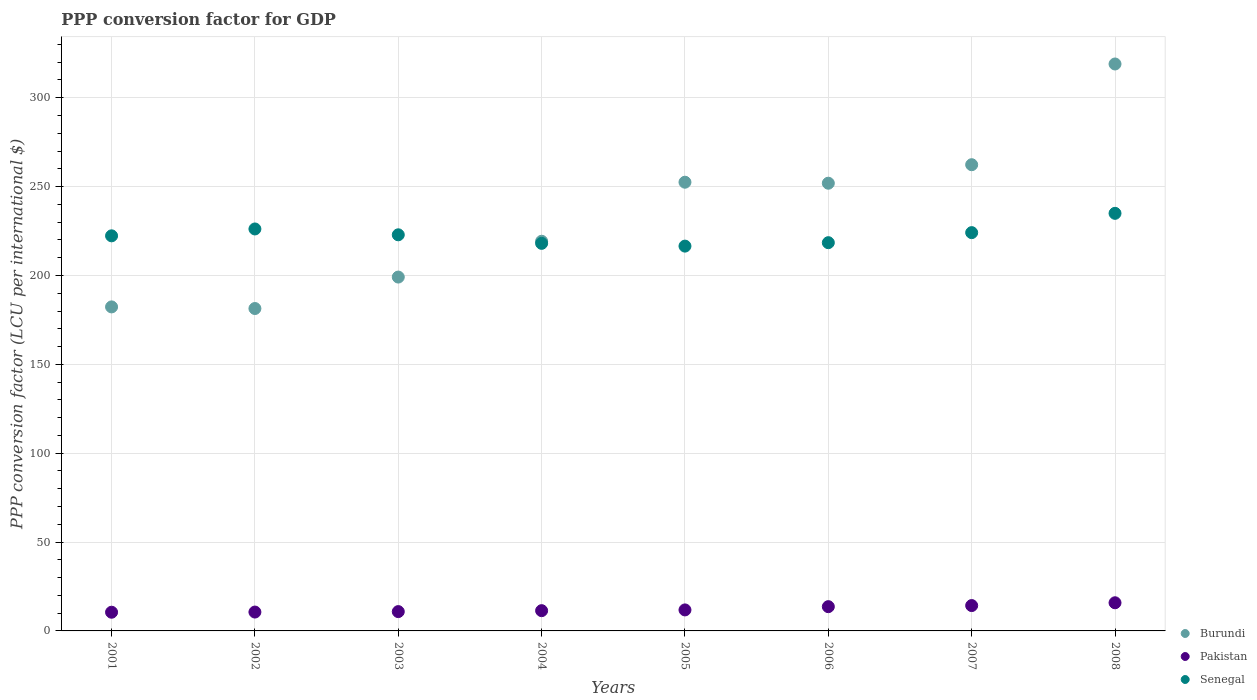How many different coloured dotlines are there?
Offer a very short reply. 3. Is the number of dotlines equal to the number of legend labels?
Ensure brevity in your answer.  Yes. What is the PPP conversion factor for GDP in Burundi in 2001?
Keep it short and to the point. 182.31. Across all years, what is the maximum PPP conversion factor for GDP in Senegal?
Make the answer very short. 234.95. Across all years, what is the minimum PPP conversion factor for GDP in Burundi?
Ensure brevity in your answer.  181.4. In which year was the PPP conversion factor for GDP in Burundi minimum?
Offer a very short reply. 2002. What is the total PPP conversion factor for GDP in Senegal in the graph?
Give a very brief answer. 1783.41. What is the difference between the PPP conversion factor for GDP in Pakistan in 2002 and that in 2003?
Offer a very short reply. -0.25. What is the difference between the PPP conversion factor for GDP in Pakistan in 2003 and the PPP conversion factor for GDP in Burundi in 2008?
Provide a succinct answer. -308.12. What is the average PPP conversion factor for GDP in Senegal per year?
Provide a short and direct response. 222.93. In the year 2001, what is the difference between the PPP conversion factor for GDP in Burundi and PPP conversion factor for GDP in Senegal?
Your response must be concise. -39.99. What is the ratio of the PPP conversion factor for GDP in Senegal in 2002 to that in 2004?
Give a very brief answer. 1.04. Is the difference between the PPP conversion factor for GDP in Burundi in 2003 and 2005 greater than the difference between the PPP conversion factor for GDP in Senegal in 2003 and 2005?
Offer a terse response. No. What is the difference between the highest and the second highest PPP conversion factor for GDP in Pakistan?
Your response must be concise. 1.57. What is the difference between the highest and the lowest PPP conversion factor for GDP in Pakistan?
Provide a short and direct response. 5.32. Is the sum of the PPP conversion factor for GDP in Senegal in 2003 and 2005 greater than the maximum PPP conversion factor for GDP in Burundi across all years?
Give a very brief answer. Yes. Is it the case that in every year, the sum of the PPP conversion factor for GDP in Pakistan and PPP conversion factor for GDP in Burundi  is greater than the PPP conversion factor for GDP in Senegal?
Give a very brief answer. No. Does the PPP conversion factor for GDP in Senegal monotonically increase over the years?
Ensure brevity in your answer.  No. Is the PPP conversion factor for GDP in Burundi strictly less than the PPP conversion factor for GDP in Senegal over the years?
Give a very brief answer. No. How many dotlines are there?
Make the answer very short. 3. Are the values on the major ticks of Y-axis written in scientific E-notation?
Keep it short and to the point. No. Does the graph contain any zero values?
Give a very brief answer. No. How many legend labels are there?
Your answer should be very brief. 3. How are the legend labels stacked?
Keep it short and to the point. Vertical. What is the title of the graph?
Offer a terse response. PPP conversion factor for GDP. Does "Liechtenstein" appear as one of the legend labels in the graph?
Your response must be concise. No. What is the label or title of the X-axis?
Offer a very short reply. Years. What is the label or title of the Y-axis?
Provide a short and direct response. PPP conversion factor (LCU per international $). What is the PPP conversion factor (LCU per international $) of Burundi in 2001?
Give a very brief answer. 182.31. What is the PPP conversion factor (LCU per international $) in Pakistan in 2001?
Offer a terse response. 10.52. What is the PPP conversion factor (LCU per international $) in Senegal in 2001?
Give a very brief answer. 222.3. What is the PPP conversion factor (LCU per international $) in Burundi in 2002?
Your answer should be very brief. 181.4. What is the PPP conversion factor (LCU per international $) in Pakistan in 2002?
Give a very brief answer. 10.61. What is the PPP conversion factor (LCU per international $) in Senegal in 2002?
Ensure brevity in your answer.  226.16. What is the PPP conversion factor (LCU per international $) in Burundi in 2003?
Provide a succinct answer. 199.1. What is the PPP conversion factor (LCU per international $) in Pakistan in 2003?
Your answer should be compact. 10.87. What is the PPP conversion factor (LCU per international $) in Senegal in 2003?
Your answer should be compact. 222.88. What is the PPP conversion factor (LCU per international $) in Burundi in 2004?
Make the answer very short. 219.24. What is the PPP conversion factor (LCU per international $) in Pakistan in 2004?
Your answer should be compact. 11.4. What is the PPP conversion factor (LCU per international $) in Senegal in 2004?
Provide a short and direct response. 218.06. What is the PPP conversion factor (LCU per international $) in Burundi in 2005?
Make the answer very short. 252.46. What is the PPP conversion factor (LCU per international $) of Pakistan in 2005?
Keep it short and to the point. 11.82. What is the PPP conversion factor (LCU per international $) of Senegal in 2005?
Provide a succinct answer. 216.51. What is the PPP conversion factor (LCU per international $) of Burundi in 2006?
Ensure brevity in your answer.  251.91. What is the PPP conversion factor (LCU per international $) of Pakistan in 2006?
Your response must be concise. 13.65. What is the PPP conversion factor (LCU per international $) of Senegal in 2006?
Give a very brief answer. 218.44. What is the PPP conversion factor (LCU per international $) of Burundi in 2007?
Your response must be concise. 262.31. What is the PPP conversion factor (LCU per international $) in Pakistan in 2007?
Provide a short and direct response. 14.26. What is the PPP conversion factor (LCU per international $) of Senegal in 2007?
Your answer should be very brief. 224.1. What is the PPP conversion factor (LCU per international $) of Burundi in 2008?
Your answer should be compact. 318.99. What is the PPP conversion factor (LCU per international $) of Pakistan in 2008?
Give a very brief answer. 15.84. What is the PPP conversion factor (LCU per international $) of Senegal in 2008?
Ensure brevity in your answer.  234.95. Across all years, what is the maximum PPP conversion factor (LCU per international $) of Burundi?
Provide a succinct answer. 318.99. Across all years, what is the maximum PPP conversion factor (LCU per international $) of Pakistan?
Make the answer very short. 15.84. Across all years, what is the maximum PPP conversion factor (LCU per international $) in Senegal?
Give a very brief answer. 234.95. Across all years, what is the minimum PPP conversion factor (LCU per international $) in Burundi?
Make the answer very short. 181.4. Across all years, what is the minimum PPP conversion factor (LCU per international $) of Pakistan?
Keep it short and to the point. 10.52. Across all years, what is the minimum PPP conversion factor (LCU per international $) in Senegal?
Keep it short and to the point. 216.51. What is the total PPP conversion factor (LCU per international $) in Burundi in the graph?
Provide a succinct answer. 1867.72. What is the total PPP conversion factor (LCU per international $) in Pakistan in the graph?
Provide a succinct answer. 98.96. What is the total PPP conversion factor (LCU per international $) in Senegal in the graph?
Ensure brevity in your answer.  1783.41. What is the difference between the PPP conversion factor (LCU per international $) in Burundi in 2001 and that in 2002?
Provide a short and direct response. 0.91. What is the difference between the PPP conversion factor (LCU per international $) of Pakistan in 2001 and that in 2002?
Ensure brevity in your answer.  -0.1. What is the difference between the PPP conversion factor (LCU per international $) in Senegal in 2001 and that in 2002?
Give a very brief answer. -3.86. What is the difference between the PPP conversion factor (LCU per international $) in Burundi in 2001 and that in 2003?
Make the answer very short. -16.79. What is the difference between the PPP conversion factor (LCU per international $) of Pakistan in 2001 and that in 2003?
Offer a terse response. -0.35. What is the difference between the PPP conversion factor (LCU per international $) in Senegal in 2001 and that in 2003?
Provide a succinct answer. -0.58. What is the difference between the PPP conversion factor (LCU per international $) of Burundi in 2001 and that in 2004?
Give a very brief answer. -36.93. What is the difference between the PPP conversion factor (LCU per international $) of Pakistan in 2001 and that in 2004?
Provide a short and direct response. -0.88. What is the difference between the PPP conversion factor (LCU per international $) of Senegal in 2001 and that in 2004?
Offer a very short reply. 4.24. What is the difference between the PPP conversion factor (LCU per international $) of Burundi in 2001 and that in 2005?
Offer a very short reply. -70.15. What is the difference between the PPP conversion factor (LCU per international $) of Pakistan in 2001 and that in 2005?
Make the answer very short. -1.3. What is the difference between the PPP conversion factor (LCU per international $) in Senegal in 2001 and that in 2005?
Your answer should be very brief. 5.79. What is the difference between the PPP conversion factor (LCU per international $) of Burundi in 2001 and that in 2006?
Provide a succinct answer. -69.6. What is the difference between the PPP conversion factor (LCU per international $) of Pakistan in 2001 and that in 2006?
Keep it short and to the point. -3.13. What is the difference between the PPP conversion factor (LCU per international $) in Senegal in 2001 and that in 2006?
Offer a terse response. 3.86. What is the difference between the PPP conversion factor (LCU per international $) in Burundi in 2001 and that in 2007?
Give a very brief answer. -80. What is the difference between the PPP conversion factor (LCU per international $) of Pakistan in 2001 and that in 2007?
Offer a very short reply. -3.75. What is the difference between the PPP conversion factor (LCU per international $) in Senegal in 2001 and that in 2007?
Offer a very short reply. -1.8. What is the difference between the PPP conversion factor (LCU per international $) in Burundi in 2001 and that in 2008?
Give a very brief answer. -136.68. What is the difference between the PPP conversion factor (LCU per international $) of Pakistan in 2001 and that in 2008?
Your response must be concise. -5.32. What is the difference between the PPP conversion factor (LCU per international $) of Senegal in 2001 and that in 2008?
Make the answer very short. -12.65. What is the difference between the PPP conversion factor (LCU per international $) in Burundi in 2002 and that in 2003?
Offer a terse response. -17.7. What is the difference between the PPP conversion factor (LCU per international $) in Pakistan in 2002 and that in 2003?
Offer a very short reply. -0.25. What is the difference between the PPP conversion factor (LCU per international $) in Senegal in 2002 and that in 2003?
Offer a terse response. 3.29. What is the difference between the PPP conversion factor (LCU per international $) in Burundi in 2002 and that in 2004?
Provide a succinct answer. -37.84. What is the difference between the PPP conversion factor (LCU per international $) of Pakistan in 2002 and that in 2004?
Make the answer very short. -0.78. What is the difference between the PPP conversion factor (LCU per international $) in Senegal in 2002 and that in 2004?
Offer a terse response. 8.1. What is the difference between the PPP conversion factor (LCU per international $) of Burundi in 2002 and that in 2005?
Your answer should be compact. -71.06. What is the difference between the PPP conversion factor (LCU per international $) in Pakistan in 2002 and that in 2005?
Offer a terse response. -1.2. What is the difference between the PPP conversion factor (LCU per international $) of Senegal in 2002 and that in 2005?
Give a very brief answer. 9.65. What is the difference between the PPP conversion factor (LCU per international $) of Burundi in 2002 and that in 2006?
Your answer should be very brief. -70.51. What is the difference between the PPP conversion factor (LCU per international $) of Pakistan in 2002 and that in 2006?
Ensure brevity in your answer.  -3.04. What is the difference between the PPP conversion factor (LCU per international $) in Senegal in 2002 and that in 2006?
Make the answer very short. 7.72. What is the difference between the PPP conversion factor (LCU per international $) of Burundi in 2002 and that in 2007?
Make the answer very short. -80.91. What is the difference between the PPP conversion factor (LCU per international $) of Pakistan in 2002 and that in 2007?
Ensure brevity in your answer.  -3.65. What is the difference between the PPP conversion factor (LCU per international $) in Senegal in 2002 and that in 2007?
Offer a terse response. 2.07. What is the difference between the PPP conversion factor (LCU per international $) of Burundi in 2002 and that in 2008?
Provide a succinct answer. -137.59. What is the difference between the PPP conversion factor (LCU per international $) of Pakistan in 2002 and that in 2008?
Ensure brevity in your answer.  -5.22. What is the difference between the PPP conversion factor (LCU per international $) in Senegal in 2002 and that in 2008?
Ensure brevity in your answer.  -8.79. What is the difference between the PPP conversion factor (LCU per international $) in Burundi in 2003 and that in 2004?
Provide a succinct answer. -20.15. What is the difference between the PPP conversion factor (LCU per international $) of Pakistan in 2003 and that in 2004?
Keep it short and to the point. -0.53. What is the difference between the PPP conversion factor (LCU per international $) in Senegal in 2003 and that in 2004?
Give a very brief answer. 4.81. What is the difference between the PPP conversion factor (LCU per international $) of Burundi in 2003 and that in 2005?
Your answer should be very brief. -53.36. What is the difference between the PPP conversion factor (LCU per international $) in Pakistan in 2003 and that in 2005?
Your response must be concise. -0.95. What is the difference between the PPP conversion factor (LCU per international $) in Senegal in 2003 and that in 2005?
Give a very brief answer. 6.37. What is the difference between the PPP conversion factor (LCU per international $) of Burundi in 2003 and that in 2006?
Your response must be concise. -52.81. What is the difference between the PPP conversion factor (LCU per international $) in Pakistan in 2003 and that in 2006?
Keep it short and to the point. -2.78. What is the difference between the PPP conversion factor (LCU per international $) of Senegal in 2003 and that in 2006?
Provide a succinct answer. 4.43. What is the difference between the PPP conversion factor (LCU per international $) of Burundi in 2003 and that in 2007?
Offer a terse response. -63.21. What is the difference between the PPP conversion factor (LCU per international $) in Pakistan in 2003 and that in 2007?
Give a very brief answer. -3.39. What is the difference between the PPP conversion factor (LCU per international $) in Senegal in 2003 and that in 2007?
Keep it short and to the point. -1.22. What is the difference between the PPP conversion factor (LCU per international $) in Burundi in 2003 and that in 2008?
Offer a very short reply. -119.89. What is the difference between the PPP conversion factor (LCU per international $) of Pakistan in 2003 and that in 2008?
Make the answer very short. -4.97. What is the difference between the PPP conversion factor (LCU per international $) of Senegal in 2003 and that in 2008?
Offer a very short reply. -12.07. What is the difference between the PPP conversion factor (LCU per international $) in Burundi in 2004 and that in 2005?
Offer a very short reply. -33.22. What is the difference between the PPP conversion factor (LCU per international $) of Pakistan in 2004 and that in 2005?
Ensure brevity in your answer.  -0.42. What is the difference between the PPP conversion factor (LCU per international $) in Senegal in 2004 and that in 2005?
Your answer should be very brief. 1.55. What is the difference between the PPP conversion factor (LCU per international $) in Burundi in 2004 and that in 2006?
Offer a terse response. -32.66. What is the difference between the PPP conversion factor (LCU per international $) in Pakistan in 2004 and that in 2006?
Provide a succinct answer. -2.25. What is the difference between the PPP conversion factor (LCU per international $) in Senegal in 2004 and that in 2006?
Ensure brevity in your answer.  -0.38. What is the difference between the PPP conversion factor (LCU per international $) of Burundi in 2004 and that in 2007?
Provide a succinct answer. -43.07. What is the difference between the PPP conversion factor (LCU per international $) of Pakistan in 2004 and that in 2007?
Your answer should be compact. -2.87. What is the difference between the PPP conversion factor (LCU per international $) in Senegal in 2004 and that in 2007?
Ensure brevity in your answer.  -6.03. What is the difference between the PPP conversion factor (LCU per international $) of Burundi in 2004 and that in 2008?
Offer a terse response. -99.74. What is the difference between the PPP conversion factor (LCU per international $) in Pakistan in 2004 and that in 2008?
Keep it short and to the point. -4.44. What is the difference between the PPP conversion factor (LCU per international $) in Senegal in 2004 and that in 2008?
Make the answer very short. -16.89. What is the difference between the PPP conversion factor (LCU per international $) in Burundi in 2005 and that in 2006?
Give a very brief answer. 0.56. What is the difference between the PPP conversion factor (LCU per international $) of Pakistan in 2005 and that in 2006?
Give a very brief answer. -1.83. What is the difference between the PPP conversion factor (LCU per international $) in Senegal in 2005 and that in 2006?
Ensure brevity in your answer.  -1.93. What is the difference between the PPP conversion factor (LCU per international $) in Burundi in 2005 and that in 2007?
Provide a succinct answer. -9.85. What is the difference between the PPP conversion factor (LCU per international $) in Pakistan in 2005 and that in 2007?
Ensure brevity in your answer.  -2.45. What is the difference between the PPP conversion factor (LCU per international $) of Senegal in 2005 and that in 2007?
Your answer should be very brief. -7.58. What is the difference between the PPP conversion factor (LCU per international $) of Burundi in 2005 and that in 2008?
Keep it short and to the point. -66.52. What is the difference between the PPP conversion factor (LCU per international $) in Pakistan in 2005 and that in 2008?
Offer a very short reply. -4.02. What is the difference between the PPP conversion factor (LCU per international $) in Senegal in 2005 and that in 2008?
Offer a very short reply. -18.44. What is the difference between the PPP conversion factor (LCU per international $) of Burundi in 2006 and that in 2007?
Your answer should be very brief. -10.41. What is the difference between the PPP conversion factor (LCU per international $) in Pakistan in 2006 and that in 2007?
Give a very brief answer. -0.61. What is the difference between the PPP conversion factor (LCU per international $) of Senegal in 2006 and that in 2007?
Make the answer very short. -5.65. What is the difference between the PPP conversion factor (LCU per international $) in Burundi in 2006 and that in 2008?
Provide a short and direct response. -67.08. What is the difference between the PPP conversion factor (LCU per international $) of Pakistan in 2006 and that in 2008?
Your response must be concise. -2.19. What is the difference between the PPP conversion factor (LCU per international $) of Senegal in 2006 and that in 2008?
Your response must be concise. -16.51. What is the difference between the PPP conversion factor (LCU per international $) of Burundi in 2007 and that in 2008?
Provide a short and direct response. -56.67. What is the difference between the PPP conversion factor (LCU per international $) in Pakistan in 2007 and that in 2008?
Keep it short and to the point. -1.57. What is the difference between the PPP conversion factor (LCU per international $) in Senegal in 2007 and that in 2008?
Provide a succinct answer. -10.86. What is the difference between the PPP conversion factor (LCU per international $) in Burundi in 2001 and the PPP conversion factor (LCU per international $) in Pakistan in 2002?
Your answer should be compact. 171.7. What is the difference between the PPP conversion factor (LCU per international $) in Burundi in 2001 and the PPP conversion factor (LCU per international $) in Senegal in 2002?
Your response must be concise. -43.85. What is the difference between the PPP conversion factor (LCU per international $) in Pakistan in 2001 and the PPP conversion factor (LCU per international $) in Senegal in 2002?
Keep it short and to the point. -215.64. What is the difference between the PPP conversion factor (LCU per international $) in Burundi in 2001 and the PPP conversion factor (LCU per international $) in Pakistan in 2003?
Your answer should be very brief. 171.44. What is the difference between the PPP conversion factor (LCU per international $) in Burundi in 2001 and the PPP conversion factor (LCU per international $) in Senegal in 2003?
Offer a very short reply. -40.57. What is the difference between the PPP conversion factor (LCU per international $) of Pakistan in 2001 and the PPP conversion factor (LCU per international $) of Senegal in 2003?
Your answer should be compact. -212.36. What is the difference between the PPP conversion factor (LCU per international $) in Burundi in 2001 and the PPP conversion factor (LCU per international $) in Pakistan in 2004?
Your response must be concise. 170.91. What is the difference between the PPP conversion factor (LCU per international $) in Burundi in 2001 and the PPP conversion factor (LCU per international $) in Senegal in 2004?
Give a very brief answer. -35.75. What is the difference between the PPP conversion factor (LCU per international $) of Pakistan in 2001 and the PPP conversion factor (LCU per international $) of Senegal in 2004?
Provide a succinct answer. -207.55. What is the difference between the PPP conversion factor (LCU per international $) in Burundi in 2001 and the PPP conversion factor (LCU per international $) in Pakistan in 2005?
Make the answer very short. 170.49. What is the difference between the PPP conversion factor (LCU per international $) in Burundi in 2001 and the PPP conversion factor (LCU per international $) in Senegal in 2005?
Your answer should be very brief. -34.2. What is the difference between the PPP conversion factor (LCU per international $) in Pakistan in 2001 and the PPP conversion factor (LCU per international $) in Senegal in 2005?
Provide a short and direct response. -205.99. What is the difference between the PPP conversion factor (LCU per international $) in Burundi in 2001 and the PPP conversion factor (LCU per international $) in Pakistan in 2006?
Offer a terse response. 168.66. What is the difference between the PPP conversion factor (LCU per international $) in Burundi in 2001 and the PPP conversion factor (LCU per international $) in Senegal in 2006?
Keep it short and to the point. -36.13. What is the difference between the PPP conversion factor (LCU per international $) of Pakistan in 2001 and the PPP conversion factor (LCU per international $) of Senegal in 2006?
Ensure brevity in your answer.  -207.93. What is the difference between the PPP conversion factor (LCU per international $) in Burundi in 2001 and the PPP conversion factor (LCU per international $) in Pakistan in 2007?
Keep it short and to the point. 168.05. What is the difference between the PPP conversion factor (LCU per international $) in Burundi in 2001 and the PPP conversion factor (LCU per international $) in Senegal in 2007?
Your answer should be compact. -41.79. What is the difference between the PPP conversion factor (LCU per international $) in Pakistan in 2001 and the PPP conversion factor (LCU per international $) in Senegal in 2007?
Keep it short and to the point. -213.58. What is the difference between the PPP conversion factor (LCU per international $) of Burundi in 2001 and the PPP conversion factor (LCU per international $) of Pakistan in 2008?
Give a very brief answer. 166.47. What is the difference between the PPP conversion factor (LCU per international $) in Burundi in 2001 and the PPP conversion factor (LCU per international $) in Senegal in 2008?
Your answer should be very brief. -52.64. What is the difference between the PPP conversion factor (LCU per international $) of Pakistan in 2001 and the PPP conversion factor (LCU per international $) of Senegal in 2008?
Make the answer very short. -224.43. What is the difference between the PPP conversion factor (LCU per international $) of Burundi in 2002 and the PPP conversion factor (LCU per international $) of Pakistan in 2003?
Your response must be concise. 170.53. What is the difference between the PPP conversion factor (LCU per international $) of Burundi in 2002 and the PPP conversion factor (LCU per international $) of Senegal in 2003?
Provide a succinct answer. -41.48. What is the difference between the PPP conversion factor (LCU per international $) in Pakistan in 2002 and the PPP conversion factor (LCU per international $) in Senegal in 2003?
Provide a succinct answer. -212.26. What is the difference between the PPP conversion factor (LCU per international $) of Burundi in 2002 and the PPP conversion factor (LCU per international $) of Pakistan in 2004?
Your response must be concise. 170. What is the difference between the PPP conversion factor (LCU per international $) in Burundi in 2002 and the PPP conversion factor (LCU per international $) in Senegal in 2004?
Your answer should be compact. -36.66. What is the difference between the PPP conversion factor (LCU per international $) in Pakistan in 2002 and the PPP conversion factor (LCU per international $) in Senegal in 2004?
Offer a very short reply. -207.45. What is the difference between the PPP conversion factor (LCU per international $) of Burundi in 2002 and the PPP conversion factor (LCU per international $) of Pakistan in 2005?
Offer a very short reply. 169.58. What is the difference between the PPP conversion factor (LCU per international $) of Burundi in 2002 and the PPP conversion factor (LCU per international $) of Senegal in 2005?
Give a very brief answer. -35.11. What is the difference between the PPP conversion factor (LCU per international $) in Pakistan in 2002 and the PPP conversion factor (LCU per international $) in Senegal in 2005?
Make the answer very short. -205.9. What is the difference between the PPP conversion factor (LCU per international $) of Burundi in 2002 and the PPP conversion factor (LCU per international $) of Pakistan in 2006?
Provide a short and direct response. 167.75. What is the difference between the PPP conversion factor (LCU per international $) of Burundi in 2002 and the PPP conversion factor (LCU per international $) of Senegal in 2006?
Make the answer very short. -37.04. What is the difference between the PPP conversion factor (LCU per international $) of Pakistan in 2002 and the PPP conversion factor (LCU per international $) of Senegal in 2006?
Give a very brief answer. -207.83. What is the difference between the PPP conversion factor (LCU per international $) of Burundi in 2002 and the PPP conversion factor (LCU per international $) of Pakistan in 2007?
Provide a short and direct response. 167.14. What is the difference between the PPP conversion factor (LCU per international $) in Burundi in 2002 and the PPP conversion factor (LCU per international $) in Senegal in 2007?
Your answer should be compact. -42.7. What is the difference between the PPP conversion factor (LCU per international $) in Pakistan in 2002 and the PPP conversion factor (LCU per international $) in Senegal in 2007?
Provide a succinct answer. -213.48. What is the difference between the PPP conversion factor (LCU per international $) of Burundi in 2002 and the PPP conversion factor (LCU per international $) of Pakistan in 2008?
Provide a short and direct response. 165.56. What is the difference between the PPP conversion factor (LCU per international $) of Burundi in 2002 and the PPP conversion factor (LCU per international $) of Senegal in 2008?
Give a very brief answer. -53.55. What is the difference between the PPP conversion factor (LCU per international $) of Pakistan in 2002 and the PPP conversion factor (LCU per international $) of Senegal in 2008?
Offer a very short reply. -224.34. What is the difference between the PPP conversion factor (LCU per international $) of Burundi in 2003 and the PPP conversion factor (LCU per international $) of Pakistan in 2004?
Give a very brief answer. 187.7. What is the difference between the PPP conversion factor (LCU per international $) in Burundi in 2003 and the PPP conversion factor (LCU per international $) in Senegal in 2004?
Offer a terse response. -18.96. What is the difference between the PPP conversion factor (LCU per international $) of Pakistan in 2003 and the PPP conversion factor (LCU per international $) of Senegal in 2004?
Your answer should be compact. -207.19. What is the difference between the PPP conversion factor (LCU per international $) in Burundi in 2003 and the PPP conversion factor (LCU per international $) in Pakistan in 2005?
Your answer should be compact. 187.28. What is the difference between the PPP conversion factor (LCU per international $) of Burundi in 2003 and the PPP conversion factor (LCU per international $) of Senegal in 2005?
Provide a succinct answer. -17.41. What is the difference between the PPP conversion factor (LCU per international $) in Pakistan in 2003 and the PPP conversion factor (LCU per international $) in Senegal in 2005?
Your answer should be compact. -205.64. What is the difference between the PPP conversion factor (LCU per international $) in Burundi in 2003 and the PPP conversion factor (LCU per international $) in Pakistan in 2006?
Provide a succinct answer. 185.45. What is the difference between the PPP conversion factor (LCU per international $) in Burundi in 2003 and the PPP conversion factor (LCU per international $) in Senegal in 2006?
Make the answer very short. -19.34. What is the difference between the PPP conversion factor (LCU per international $) of Pakistan in 2003 and the PPP conversion factor (LCU per international $) of Senegal in 2006?
Give a very brief answer. -207.58. What is the difference between the PPP conversion factor (LCU per international $) of Burundi in 2003 and the PPP conversion factor (LCU per international $) of Pakistan in 2007?
Give a very brief answer. 184.84. What is the difference between the PPP conversion factor (LCU per international $) of Burundi in 2003 and the PPP conversion factor (LCU per international $) of Senegal in 2007?
Keep it short and to the point. -25. What is the difference between the PPP conversion factor (LCU per international $) in Pakistan in 2003 and the PPP conversion factor (LCU per international $) in Senegal in 2007?
Your response must be concise. -213.23. What is the difference between the PPP conversion factor (LCU per international $) in Burundi in 2003 and the PPP conversion factor (LCU per international $) in Pakistan in 2008?
Provide a succinct answer. 183.26. What is the difference between the PPP conversion factor (LCU per international $) in Burundi in 2003 and the PPP conversion factor (LCU per international $) in Senegal in 2008?
Keep it short and to the point. -35.85. What is the difference between the PPP conversion factor (LCU per international $) in Pakistan in 2003 and the PPP conversion factor (LCU per international $) in Senegal in 2008?
Offer a terse response. -224.08. What is the difference between the PPP conversion factor (LCU per international $) in Burundi in 2004 and the PPP conversion factor (LCU per international $) in Pakistan in 2005?
Your response must be concise. 207.43. What is the difference between the PPP conversion factor (LCU per international $) in Burundi in 2004 and the PPP conversion factor (LCU per international $) in Senegal in 2005?
Your response must be concise. 2.73. What is the difference between the PPP conversion factor (LCU per international $) of Pakistan in 2004 and the PPP conversion factor (LCU per international $) of Senegal in 2005?
Keep it short and to the point. -205.11. What is the difference between the PPP conversion factor (LCU per international $) in Burundi in 2004 and the PPP conversion factor (LCU per international $) in Pakistan in 2006?
Provide a short and direct response. 205.59. What is the difference between the PPP conversion factor (LCU per international $) of Burundi in 2004 and the PPP conversion factor (LCU per international $) of Senegal in 2006?
Your answer should be very brief. 0.8. What is the difference between the PPP conversion factor (LCU per international $) in Pakistan in 2004 and the PPP conversion factor (LCU per international $) in Senegal in 2006?
Provide a short and direct response. -207.05. What is the difference between the PPP conversion factor (LCU per international $) in Burundi in 2004 and the PPP conversion factor (LCU per international $) in Pakistan in 2007?
Your answer should be very brief. 204.98. What is the difference between the PPP conversion factor (LCU per international $) of Burundi in 2004 and the PPP conversion factor (LCU per international $) of Senegal in 2007?
Give a very brief answer. -4.85. What is the difference between the PPP conversion factor (LCU per international $) in Pakistan in 2004 and the PPP conversion factor (LCU per international $) in Senegal in 2007?
Ensure brevity in your answer.  -212.7. What is the difference between the PPP conversion factor (LCU per international $) in Burundi in 2004 and the PPP conversion factor (LCU per international $) in Pakistan in 2008?
Offer a terse response. 203.41. What is the difference between the PPP conversion factor (LCU per international $) of Burundi in 2004 and the PPP conversion factor (LCU per international $) of Senegal in 2008?
Provide a short and direct response. -15.71. What is the difference between the PPP conversion factor (LCU per international $) of Pakistan in 2004 and the PPP conversion factor (LCU per international $) of Senegal in 2008?
Offer a very short reply. -223.56. What is the difference between the PPP conversion factor (LCU per international $) in Burundi in 2005 and the PPP conversion factor (LCU per international $) in Pakistan in 2006?
Keep it short and to the point. 238.81. What is the difference between the PPP conversion factor (LCU per international $) in Burundi in 2005 and the PPP conversion factor (LCU per international $) in Senegal in 2006?
Make the answer very short. 34.02. What is the difference between the PPP conversion factor (LCU per international $) of Pakistan in 2005 and the PPP conversion factor (LCU per international $) of Senegal in 2006?
Offer a terse response. -206.63. What is the difference between the PPP conversion factor (LCU per international $) of Burundi in 2005 and the PPP conversion factor (LCU per international $) of Pakistan in 2007?
Ensure brevity in your answer.  238.2. What is the difference between the PPP conversion factor (LCU per international $) in Burundi in 2005 and the PPP conversion factor (LCU per international $) in Senegal in 2007?
Offer a terse response. 28.37. What is the difference between the PPP conversion factor (LCU per international $) of Pakistan in 2005 and the PPP conversion factor (LCU per international $) of Senegal in 2007?
Keep it short and to the point. -212.28. What is the difference between the PPP conversion factor (LCU per international $) of Burundi in 2005 and the PPP conversion factor (LCU per international $) of Pakistan in 2008?
Ensure brevity in your answer.  236.63. What is the difference between the PPP conversion factor (LCU per international $) of Burundi in 2005 and the PPP conversion factor (LCU per international $) of Senegal in 2008?
Give a very brief answer. 17.51. What is the difference between the PPP conversion factor (LCU per international $) in Pakistan in 2005 and the PPP conversion factor (LCU per international $) in Senegal in 2008?
Offer a very short reply. -223.13. What is the difference between the PPP conversion factor (LCU per international $) of Burundi in 2006 and the PPP conversion factor (LCU per international $) of Pakistan in 2007?
Your response must be concise. 237.64. What is the difference between the PPP conversion factor (LCU per international $) of Burundi in 2006 and the PPP conversion factor (LCU per international $) of Senegal in 2007?
Your answer should be compact. 27.81. What is the difference between the PPP conversion factor (LCU per international $) of Pakistan in 2006 and the PPP conversion factor (LCU per international $) of Senegal in 2007?
Provide a short and direct response. -210.45. What is the difference between the PPP conversion factor (LCU per international $) in Burundi in 2006 and the PPP conversion factor (LCU per international $) in Pakistan in 2008?
Offer a very short reply. 236.07. What is the difference between the PPP conversion factor (LCU per international $) of Burundi in 2006 and the PPP conversion factor (LCU per international $) of Senegal in 2008?
Your answer should be very brief. 16.95. What is the difference between the PPP conversion factor (LCU per international $) of Pakistan in 2006 and the PPP conversion factor (LCU per international $) of Senegal in 2008?
Make the answer very short. -221.3. What is the difference between the PPP conversion factor (LCU per international $) of Burundi in 2007 and the PPP conversion factor (LCU per international $) of Pakistan in 2008?
Keep it short and to the point. 246.48. What is the difference between the PPP conversion factor (LCU per international $) in Burundi in 2007 and the PPP conversion factor (LCU per international $) in Senegal in 2008?
Offer a terse response. 27.36. What is the difference between the PPP conversion factor (LCU per international $) in Pakistan in 2007 and the PPP conversion factor (LCU per international $) in Senegal in 2008?
Offer a terse response. -220.69. What is the average PPP conversion factor (LCU per international $) of Burundi per year?
Provide a short and direct response. 233.47. What is the average PPP conversion factor (LCU per international $) of Pakistan per year?
Your response must be concise. 12.37. What is the average PPP conversion factor (LCU per international $) of Senegal per year?
Offer a terse response. 222.93. In the year 2001, what is the difference between the PPP conversion factor (LCU per international $) of Burundi and PPP conversion factor (LCU per international $) of Pakistan?
Your response must be concise. 171.79. In the year 2001, what is the difference between the PPP conversion factor (LCU per international $) in Burundi and PPP conversion factor (LCU per international $) in Senegal?
Offer a very short reply. -39.99. In the year 2001, what is the difference between the PPP conversion factor (LCU per international $) of Pakistan and PPP conversion factor (LCU per international $) of Senegal?
Provide a short and direct response. -211.78. In the year 2002, what is the difference between the PPP conversion factor (LCU per international $) of Burundi and PPP conversion factor (LCU per international $) of Pakistan?
Offer a terse response. 170.79. In the year 2002, what is the difference between the PPP conversion factor (LCU per international $) of Burundi and PPP conversion factor (LCU per international $) of Senegal?
Offer a very short reply. -44.76. In the year 2002, what is the difference between the PPP conversion factor (LCU per international $) in Pakistan and PPP conversion factor (LCU per international $) in Senegal?
Make the answer very short. -215.55. In the year 2003, what is the difference between the PPP conversion factor (LCU per international $) of Burundi and PPP conversion factor (LCU per international $) of Pakistan?
Your answer should be compact. 188.23. In the year 2003, what is the difference between the PPP conversion factor (LCU per international $) of Burundi and PPP conversion factor (LCU per international $) of Senegal?
Offer a very short reply. -23.78. In the year 2003, what is the difference between the PPP conversion factor (LCU per international $) in Pakistan and PPP conversion factor (LCU per international $) in Senegal?
Provide a short and direct response. -212.01. In the year 2004, what is the difference between the PPP conversion factor (LCU per international $) of Burundi and PPP conversion factor (LCU per international $) of Pakistan?
Keep it short and to the point. 207.85. In the year 2004, what is the difference between the PPP conversion factor (LCU per international $) in Burundi and PPP conversion factor (LCU per international $) in Senegal?
Your answer should be compact. 1.18. In the year 2004, what is the difference between the PPP conversion factor (LCU per international $) of Pakistan and PPP conversion factor (LCU per international $) of Senegal?
Your answer should be very brief. -206.67. In the year 2005, what is the difference between the PPP conversion factor (LCU per international $) in Burundi and PPP conversion factor (LCU per international $) in Pakistan?
Give a very brief answer. 240.65. In the year 2005, what is the difference between the PPP conversion factor (LCU per international $) of Burundi and PPP conversion factor (LCU per international $) of Senegal?
Your answer should be compact. 35.95. In the year 2005, what is the difference between the PPP conversion factor (LCU per international $) in Pakistan and PPP conversion factor (LCU per international $) in Senegal?
Your response must be concise. -204.69. In the year 2006, what is the difference between the PPP conversion factor (LCU per international $) in Burundi and PPP conversion factor (LCU per international $) in Pakistan?
Your response must be concise. 238.26. In the year 2006, what is the difference between the PPP conversion factor (LCU per international $) of Burundi and PPP conversion factor (LCU per international $) of Senegal?
Provide a succinct answer. 33.46. In the year 2006, what is the difference between the PPP conversion factor (LCU per international $) in Pakistan and PPP conversion factor (LCU per international $) in Senegal?
Your response must be concise. -204.79. In the year 2007, what is the difference between the PPP conversion factor (LCU per international $) in Burundi and PPP conversion factor (LCU per international $) in Pakistan?
Provide a short and direct response. 248.05. In the year 2007, what is the difference between the PPP conversion factor (LCU per international $) in Burundi and PPP conversion factor (LCU per international $) in Senegal?
Provide a succinct answer. 38.22. In the year 2007, what is the difference between the PPP conversion factor (LCU per international $) of Pakistan and PPP conversion factor (LCU per international $) of Senegal?
Make the answer very short. -209.83. In the year 2008, what is the difference between the PPP conversion factor (LCU per international $) in Burundi and PPP conversion factor (LCU per international $) in Pakistan?
Make the answer very short. 303.15. In the year 2008, what is the difference between the PPP conversion factor (LCU per international $) of Burundi and PPP conversion factor (LCU per international $) of Senegal?
Offer a very short reply. 84.03. In the year 2008, what is the difference between the PPP conversion factor (LCU per international $) of Pakistan and PPP conversion factor (LCU per international $) of Senegal?
Provide a short and direct response. -219.12. What is the ratio of the PPP conversion factor (LCU per international $) in Burundi in 2001 to that in 2002?
Make the answer very short. 1. What is the ratio of the PPP conversion factor (LCU per international $) in Pakistan in 2001 to that in 2002?
Provide a short and direct response. 0.99. What is the ratio of the PPP conversion factor (LCU per international $) of Senegal in 2001 to that in 2002?
Provide a succinct answer. 0.98. What is the ratio of the PPP conversion factor (LCU per international $) in Burundi in 2001 to that in 2003?
Your response must be concise. 0.92. What is the ratio of the PPP conversion factor (LCU per international $) of Pakistan in 2001 to that in 2003?
Provide a short and direct response. 0.97. What is the ratio of the PPP conversion factor (LCU per international $) in Senegal in 2001 to that in 2003?
Provide a succinct answer. 1. What is the ratio of the PPP conversion factor (LCU per international $) in Burundi in 2001 to that in 2004?
Keep it short and to the point. 0.83. What is the ratio of the PPP conversion factor (LCU per international $) in Pakistan in 2001 to that in 2004?
Your response must be concise. 0.92. What is the ratio of the PPP conversion factor (LCU per international $) in Senegal in 2001 to that in 2004?
Make the answer very short. 1.02. What is the ratio of the PPP conversion factor (LCU per international $) of Burundi in 2001 to that in 2005?
Provide a short and direct response. 0.72. What is the ratio of the PPP conversion factor (LCU per international $) in Pakistan in 2001 to that in 2005?
Your answer should be compact. 0.89. What is the ratio of the PPP conversion factor (LCU per international $) of Senegal in 2001 to that in 2005?
Offer a terse response. 1.03. What is the ratio of the PPP conversion factor (LCU per international $) in Burundi in 2001 to that in 2006?
Your answer should be very brief. 0.72. What is the ratio of the PPP conversion factor (LCU per international $) in Pakistan in 2001 to that in 2006?
Provide a short and direct response. 0.77. What is the ratio of the PPP conversion factor (LCU per international $) of Senegal in 2001 to that in 2006?
Keep it short and to the point. 1.02. What is the ratio of the PPP conversion factor (LCU per international $) of Burundi in 2001 to that in 2007?
Your answer should be very brief. 0.69. What is the ratio of the PPP conversion factor (LCU per international $) in Pakistan in 2001 to that in 2007?
Give a very brief answer. 0.74. What is the ratio of the PPP conversion factor (LCU per international $) of Senegal in 2001 to that in 2007?
Provide a succinct answer. 0.99. What is the ratio of the PPP conversion factor (LCU per international $) of Burundi in 2001 to that in 2008?
Keep it short and to the point. 0.57. What is the ratio of the PPP conversion factor (LCU per international $) in Pakistan in 2001 to that in 2008?
Provide a succinct answer. 0.66. What is the ratio of the PPP conversion factor (LCU per international $) of Senegal in 2001 to that in 2008?
Ensure brevity in your answer.  0.95. What is the ratio of the PPP conversion factor (LCU per international $) in Burundi in 2002 to that in 2003?
Ensure brevity in your answer.  0.91. What is the ratio of the PPP conversion factor (LCU per international $) in Pakistan in 2002 to that in 2003?
Your answer should be compact. 0.98. What is the ratio of the PPP conversion factor (LCU per international $) in Senegal in 2002 to that in 2003?
Your answer should be compact. 1.01. What is the ratio of the PPP conversion factor (LCU per international $) in Burundi in 2002 to that in 2004?
Your answer should be compact. 0.83. What is the ratio of the PPP conversion factor (LCU per international $) of Pakistan in 2002 to that in 2004?
Make the answer very short. 0.93. What is the ratio of the PPP conversion factor (LCU per international $) of Senegal in 2002 to that in 2004?
Keep it short and to the point. 1.04. What is the ratio of the PPP conversion factor (LCU per international $) of Burundi in 2002 to that in 2005?
Your response must be concise. 0.72. What is the ratio of the PPP conversion factor (LCU per international $) of Pakistan in 2002 to that in 2005?
Offer a terse response. 0.9. What is the ratio of the PPP conversion factor (LCU per international $) in Senegal in 2002 to that in 2005?
Offer a very short reply. 1.04. What is the ratio of the PPP conversion factor (LCU per international $) of Burundi in 2002 to that in 2006?
Provide a succinct answer. 0.72. What is the ratio of the PPP conversion factor (LCU per international $) of Pakistan in 2002 to that in 2006?
Provide a short and direct response. 0.78. What is the ratio of the PPP conversion factor (LCU per international $) in Senegal in 2002 to that in 2006?
Make the answer very short. 1.04. What is the ratio of the PPP conversion factor (LCU per international $) in Burundi in 2002 to that in 2007?
Keep it short and to the point. 0.69. What is the ratio of the PPP conversion factor (LCU per international $) of Pakistan in 2002 to that in 2007?
Provide a short and direct response. 0.74. What is the ratio of the PPP conversion factor (LCU per international $) of Senegal in 2002 to that in 2007?
Your answer should be compact. 1.01. What is the ratio of the PPP conversion factor (LCU per international $) of Burundi in 2002 to that in 2008?
Provide a short and direct response. 0.57. What is the ratio of the PPP conversion factor (LCU per international $) of Pakistan in 2002 to that in 2008?
Offer a terse response. 0.67. What is the ratio of the PPP conversion factor (LCU per international $) in Senegal in 2002 to that in 2008?
Offer a very short reply. 0.96. What is the ratio of the PPP conversion factor (LCU per international $) in Burundi in 2003 to that in 2004?
Keep it short and to the point. 0.91. What is the ratio of the PPP conversion factor (LCU per international $) in Pakistan in 2003 to that in 2004?
Your answer should be compact. 0.95. What is the ratio of the PPP conversion factor (LCU per international $) in Senegal in 2003 to that in 2004?
Ensure brevity in your answer.  1.02. What is the ratio of the PPP conversion factor (LCU per international $) of Burundi in 2003 to that in 2005?
Provide a short and direct response. 0.79. What is the ratio of the PPP conversion factor (LCU per international $) of Pakistan in 2003 to that in 2005?
Provide a succinct answer. 0.92. What is the ratio of the PPP conversion factor (LCU per international $) of Senegal in 2003 to that in 2005?
Your response must be concise. 1.03. What is the ratio of the PPP conversion factor (LCU per international $) in Burundi in 2003 to that in 2006?
Your answer should be compact. 0.79. What is the ratio of the PPP conversion factor (LCU per international $) of Pakistan in 2003 to that in 2006?
Keep it short and to the point. 0.8. What is the ratio of the PPP conversion factor (LCU per international $) in Senegal in 2003 to that in 2006?
Make the answer very short. 1.02. What is the ratio of the PPP conversion factor (LCU per international $) in Burundi in 2003 to that in 2007?
Your answer should be very brief. 0.76. What is the ratio of the PPP conversion factor (LCU per international $) of Pakistan in 2003 to that in 2007?
Give a very brief answer. 0.76. What is the ratio of the PPP conversion factor (LCU per international $) of Burundi in 2003 to that in 2008?
Keep it short and to the point. 0.62. What is the ratio of the PPP conversion factor (LCU per international $) of Pakistan in 2003 to that in 2008?
Make the answer very short. 0.69. What is the ratio of the PPP conversion factor (LCU per international $) of Senegal in 2003 to that in 2008?
Offer a very short reply. 0.95. What is the ratio of the PPP conversion factor (LCU per international $) of Burundi in 2004 to that in 2005?
Provide a succinct answer. 0.87. What is the ratio of the PPP conversion factor (LCU per international $) in Pakistan in 2004 to that in 2005?
Offer a very short reply. 0.96. What is the ratio of the PPP conversion factor (LCU per international $) in Senegal in 2004 to that in 2005?
Make the answer very short. 1.01. What is the ratio of the PPP conversion factor (LCU per international $) in Burundi in 2004 to that in 2006?
Ensure brevity in your answer.  0.87. What is the ratio of the PPP conversion factor (LCU per international $) of Pakistan in 2004 to that in 2006?
Provide a short and direct response. 0.83. What is the ratio of the PPP conversion factor (LCU per international $) of Burundi in 2004 to that in 2007?
Your response must be concise. 0.84. What is the ratio of the PPP conversion factor (LCU per international $) of Pakistan in 2004 to that in 2007?
Offer a terse response. 0.8. What is the ratio of the PPP conversion factor (LCU per international $) of Senegal in 2004 to that in 2007?
Your response must be concise. 0.97. What is the ratio of the PPP conversion factor (LCU per international $) in Burundi in 2004 to that in 2008?
Your answer should be compact. 0.69. What is the ratio of the PPP conversion factor (LCU per international $) of Pakistan in 2004 to that in 2008?
Provide a short and direct response. 0.72. What is the ratio of the PPP conversion factor (LCU per international $) of Senegal in 2004 to that in 2008?
Make the answer very short. 0.93. What is the ratio of the PPP conversion factor (LCU per international $) of Burundi in 2005 to that in 2006?
Your answer should be compact. 1. What is the ratio of the PPP conversion factor (LCU per international $) in Pakistan in 2005 to that in 2006?
Offer a very short reply. 0.87. What is the ratio of the PPP conversion factor (LCU per international $) in Senegal in 2005 to that in 2006?
Offer a terse response. 0.99. What is the ratio of the PPP conversion factor (LCU per international $) of Burundi in 2005 to that in 2007?
Your answer should be very brief. 0.96. What is the ratio of the PPP conversion factor (LCU per international $) in Pakistan in 2005 to that in 2007?
Your answer should be compact. 0.83. What is the ratio of the PPP conversion factor (LCU per international $) of Senegal in 2005 to that in 2007?
Keep it short and to the point. 0.97. What is the ratio of the PPP conversion factor (LCU per international $) of Burundi in 2005 to that in 2008?
Keep it short and to the point. 0.79. What is the ratio of the PPP conversion factor (LCU per international $) in Pakistan in 2005 to that in 2008?
Keep it short and to the point. 0.75. What is the ratio of the PPP conversion factor (LCU per international $) in Senegal in 2005 to that in 2008?
Make the answer very short. 0.92. What is the ratio of the PPP conversion factor (LCU per international $) in Burundi in 2006 to that in 2007?
Your response must be concise. 0.96. What is the ratio of the PPP conversion factor (LCU per international $) in Senegal in 2006 to that in 2007?
Offer a terse response. 0.97. What is the ratio of the PPP conversion factor (LCU per international $) of Burundi in 2006 to that in 2008?
Keep it short and to the point. 0.79. What is the ratio of the PPP conversion factor (LCU per international $) in Pakistan in 2006 to that in 2008?
Your answer should be compact. 0.86. What is the ratio of the PPP conversion factor (LCU per international $) in Senegal in 2006 to that in 2008?
Provide a short and direct response. 0.93. What is the ratio of the PPP conversion factor (LCU per international $) of Burundi in 2007 to that in 2008?
Give a very brief answer. 0.82. What is the ratio of the PPP conversion factor (LCU per international $) in Pakistan in 2007 to that in 2008?
Offer a very short reply. 0.9. What is the ratio of the PPP conversion factor (LCU per international $) in Senegal in 2007 to that in 2008?
Keep it short and to the point. 0.95. What is the difference between the highest and the second highest PPP conversion factor (LCU per international $) of Burundi?
Provide a short and direct response. 56.67. What is the difference between the highest and the second highest PPP conversion factor (LCU per international $) of Pakistan?
Make the answer very short. 1.57. What is the difference between the highest and the second highest PPP conversion factor (LCU per international $) of Senegal?
Your answer should be compact. 8.79. What is the difference between the highest and the lowest PPP conversion factor (LCU per international $) of Burundi?
Provide a succinct answer. 137.59. What is the difference between the highest and the lowest PPP conversion factor (LCU per international $) of Pakistan?
Make the answer very short. 5.32. What is the difference between the highest and the lowest PPP conversion factor (LCU per international $) in Senegal?
Make the answer very short. 18.44. 